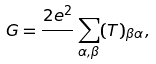Convert formula to latex. <formula><loc_0><loc_0><loc_500><loc_500>G = \frac { 2 e ^ { 2 } } { } \sum _ { \alpha , \beta } ( T ) _ { \beta \alpha } ,</formula> 